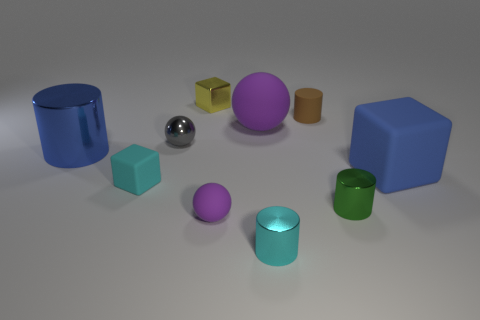Subtract all tiny cyan blocks. How many blocks are left? 2 Subtract 3 cylinders. How many cylinders are left? 1 Subtract all brown cylinders. How many cylinders are left? 3 Subtract 1 green cylinders. How many objects are left? 9 Subtract all cylinders. How many objects are left? 6 Subtract all brown spheres. Subtract all green blocks. How many spheres are left? 3 Subtract all yellow balls. How many cyan blocks are left? 1 Subtract all cyan matte things. Subtract all cylinders. How many objects are left? 5 Add 6 big rubber blocks. How many big rubber blocks are left? 7 Add 1 big cyan matte cubes. How many big cyan matte cubes exist? 1 